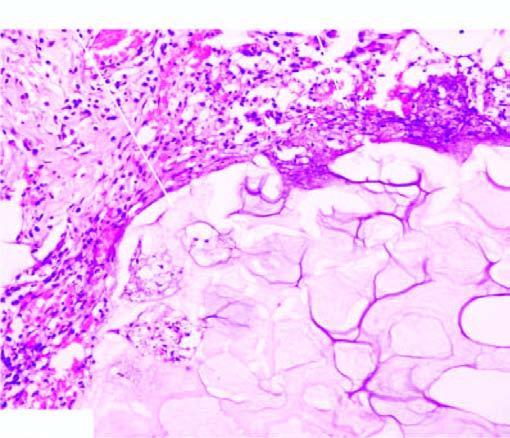what is there of adipocytes, coarse basophilic granular debris while the periphery shows a few mixed inflammatory cells?
Answer the question using a single word or phrase. Cloudy appearance 